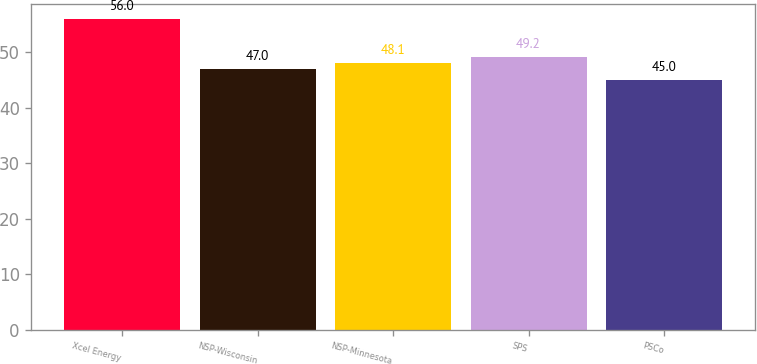<chart> <loc_0><loc_0><loc_500><loc_500><bar_chart><fcel>Xcel Energy<fcel>NSP-Wisconsin<fcel>NSP-Minnesota<fcel>SPS<fcel>PSCo<nl><fcel>56<fcel>47<fcel>48.1<fcel>49.2<fcel>45<nl></chart> 